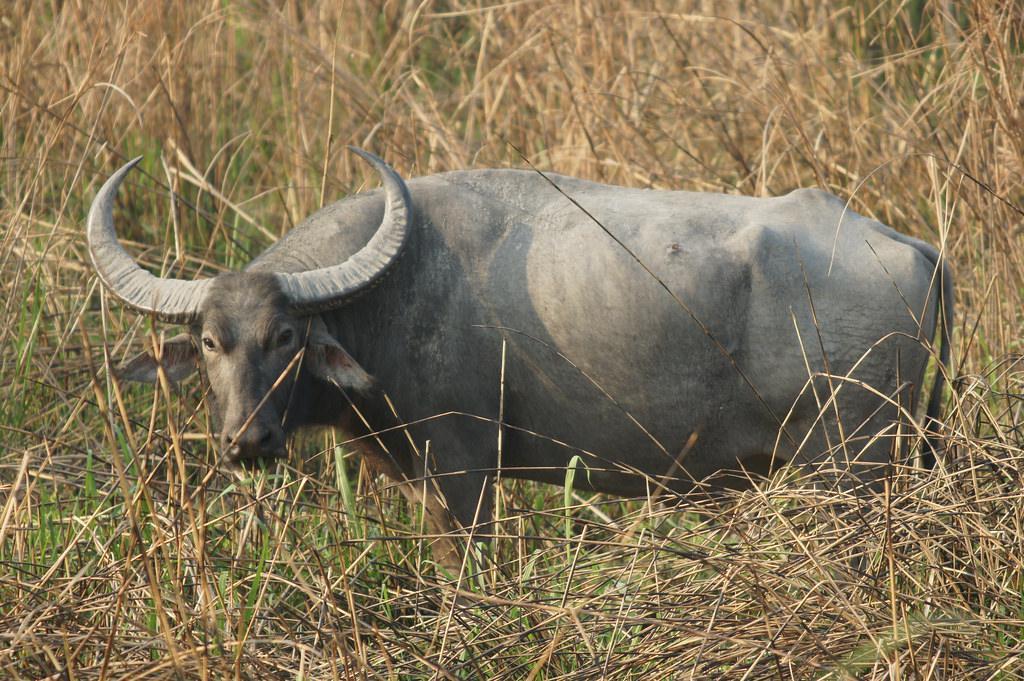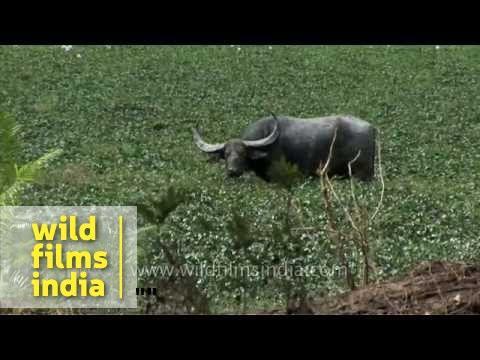The first image is the image on the left, the second image is the image on the right. Analyze the images presented: Is the assertion "The left image shows exactly one horned animal standing in a grassy area." valid? Answer yes or no. Yes. 